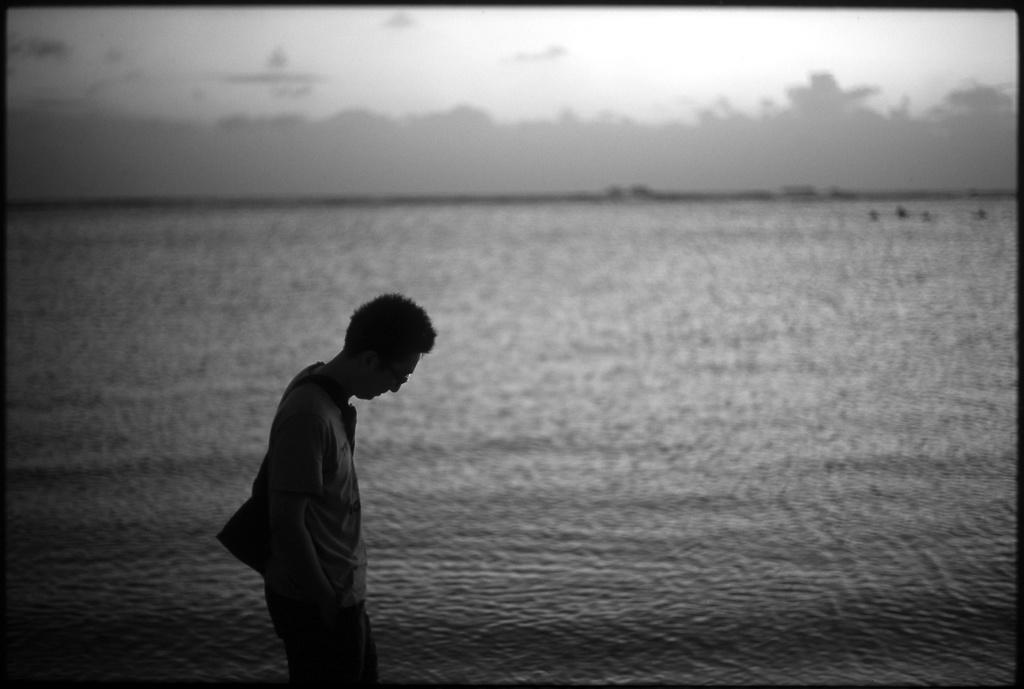How would you summarize this image in a sentence or two? This is black and white picture,there is a person standing and wore bag and we can see water. In the background we can see sky. 